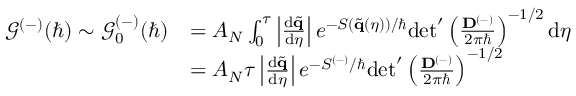Convert formula to latex. <formula><loc_0><loc_0><loc_500><loc_500>\begin{array} { r l } { \mathcal { G } ^ { ( - ) } ( \hbar { ) } \sim \mathcal { G } _ { 0 } ^ { ( - ) } ( \hbar { ) } } & { = A _ { N } \int _ { 0 } ^ { \tau } \left | \frac { d \tilde { q } } { d \eta } \right | e ^ { - S ( \tilde { q } ( \eta ) ) / } d e t ^ { \prime } \left ( \frac { D ^ { ( - ) } } { 2 \pi } \right ) ^ { - 1 / 2 } d \eta } \\ & { = A _ { N } \tau \left | \frac { d \tilde { q } } { d \eta } \right | e ^ { - S ^ { ( - ) } / } d e t ^ { \prime } \left ( \frac { D ^ { ( - ) } } { 2 \pi } \right ) ^ { - 1 / 2 } } \end{array}</formula> 